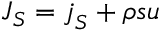<formula> <loc_0><loc_0><loc_500><loc_500>J _ { S } = j _ { S } + \rho s u</formula> 